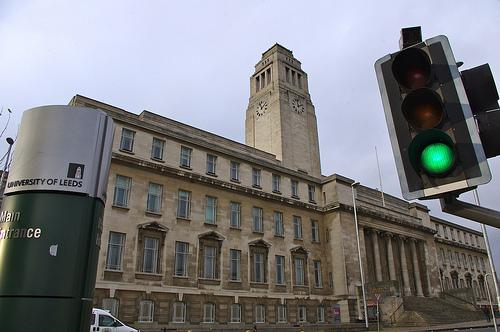Question: what color is the streetlight?
Choices:
A. Yellow.
B. Green.
C. Red.
D. White.
Answer with the letter. Answer: B Question: where is there a clock?
Choices:
A. On a watch.
B. On the wall.
C. The microwave.
D. On the tower.
Answer with the letter. Answer: D Question: how many clocks are there?
Choices:
A. One.
B. Three.
C. Two.
D. Four.
Answer with the letter. Answer: C Question: where is this photo taken?
Choices:
A. University of Leeds.
B. A mountain.
C. The beach.
D. A parade.
Answer with the letter. Answer: A Question: where does it say "Main Entrance"?
Choices:
A. The door.
B. On the sign.
C. The sidewalk.
D. The sign.
Answer with the letter. Answer: B Question: how many clock towers are there?
Choices:
A. Two.
B. Three.
C. One.
D. Four.
Answer with the letter. Answer: C 